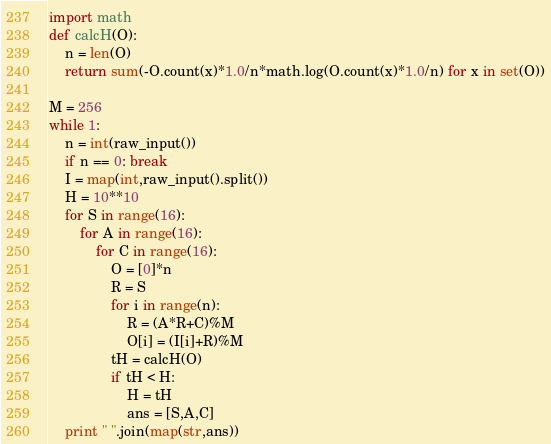Convert code to text. <code><loc_0><loc_0><loc_500><loc_500><_Python_>import math
def calcH(O):
    n = len(O)
    return sum(-O.count(x)*1.0/n*math.log(O.count(x)*1.0/n) for x in set(O))

M = 256
while 1:
    n = int(raw_input())
    if n == 0: break
    I = map(int,raw_input().split())
    H = 10**10
    for S in range(16):
        for A in range(16):
            for C in range(16):
                O = [0]*n
                R = S
                for i in range(n):
                    R = (A*R+C)%M
                    O[i] = (I[i]+R)%M
                tH = calcH(O)
                if tH < H:
                    H = tH
                    ans = [S,A,C]
    print " ".join(map(str,ans))</code> 